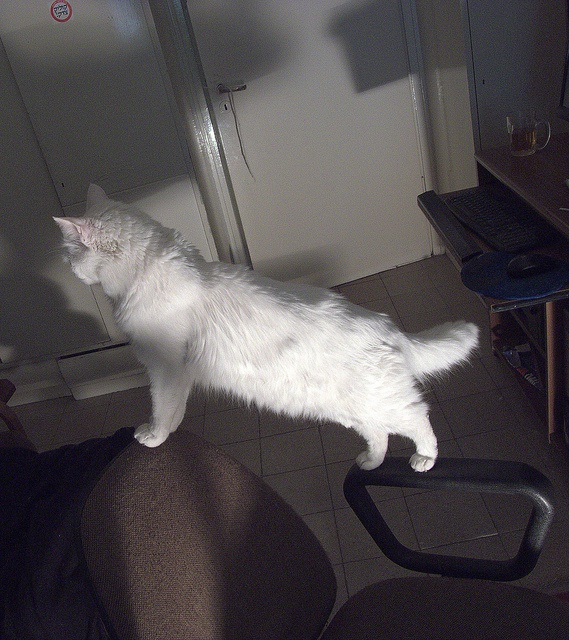Describe the objects in this image and their specific colors. I can see chair in gray, black, and navy tones, cat in gray, lightgray, and darkgray tones, keyboard in gray, black, navy, maroon, and purple tones, cup in gray, black, and navy tones, and mouse in black, navy, and gray tones in this image. 